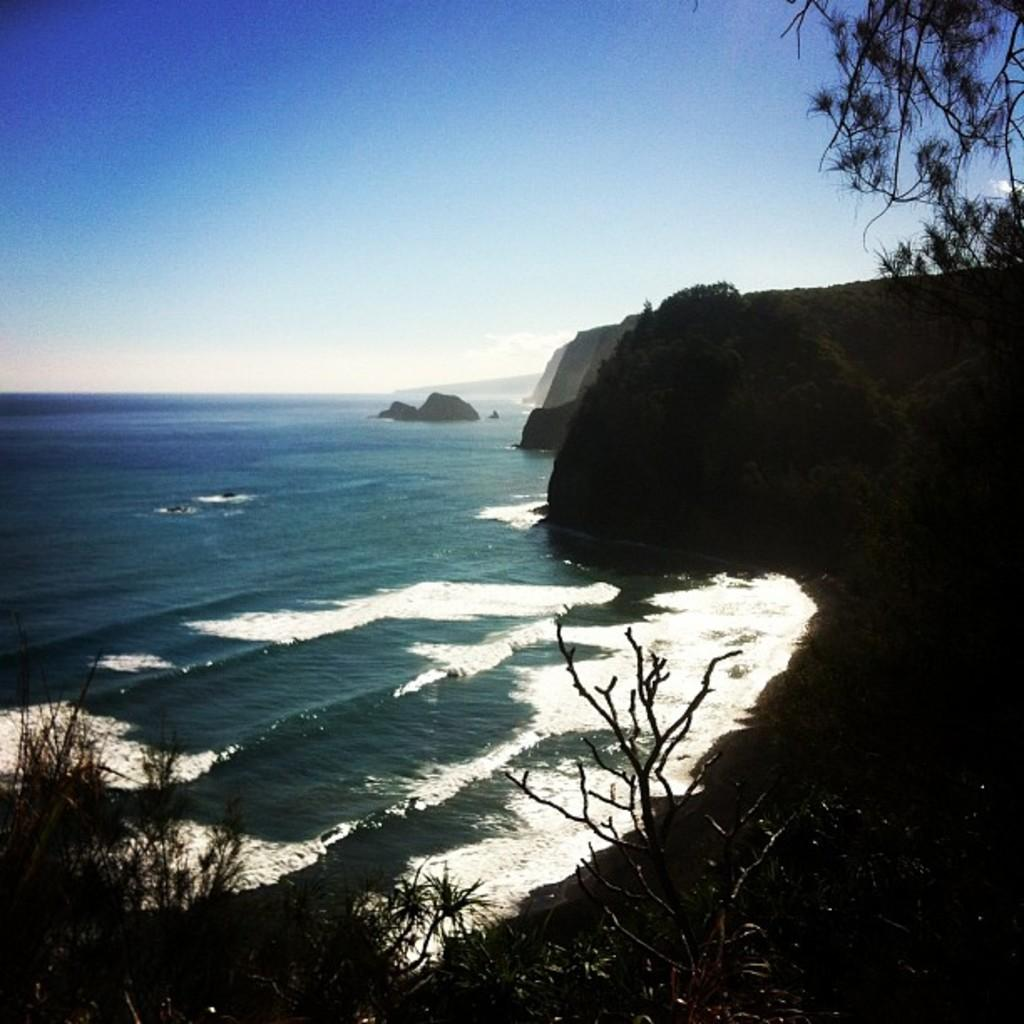What type of natural elements can be seen in the image? There are trees and hills in the image. What is located at the bottom of the image? There is water at the bottom of the image. What is visible at the top of the image? The sky is visible at the top of the image. How many chairs are placed around the station in the image? There are no chairs or stations present in the image; it features trees, hills, water, and the sky. 